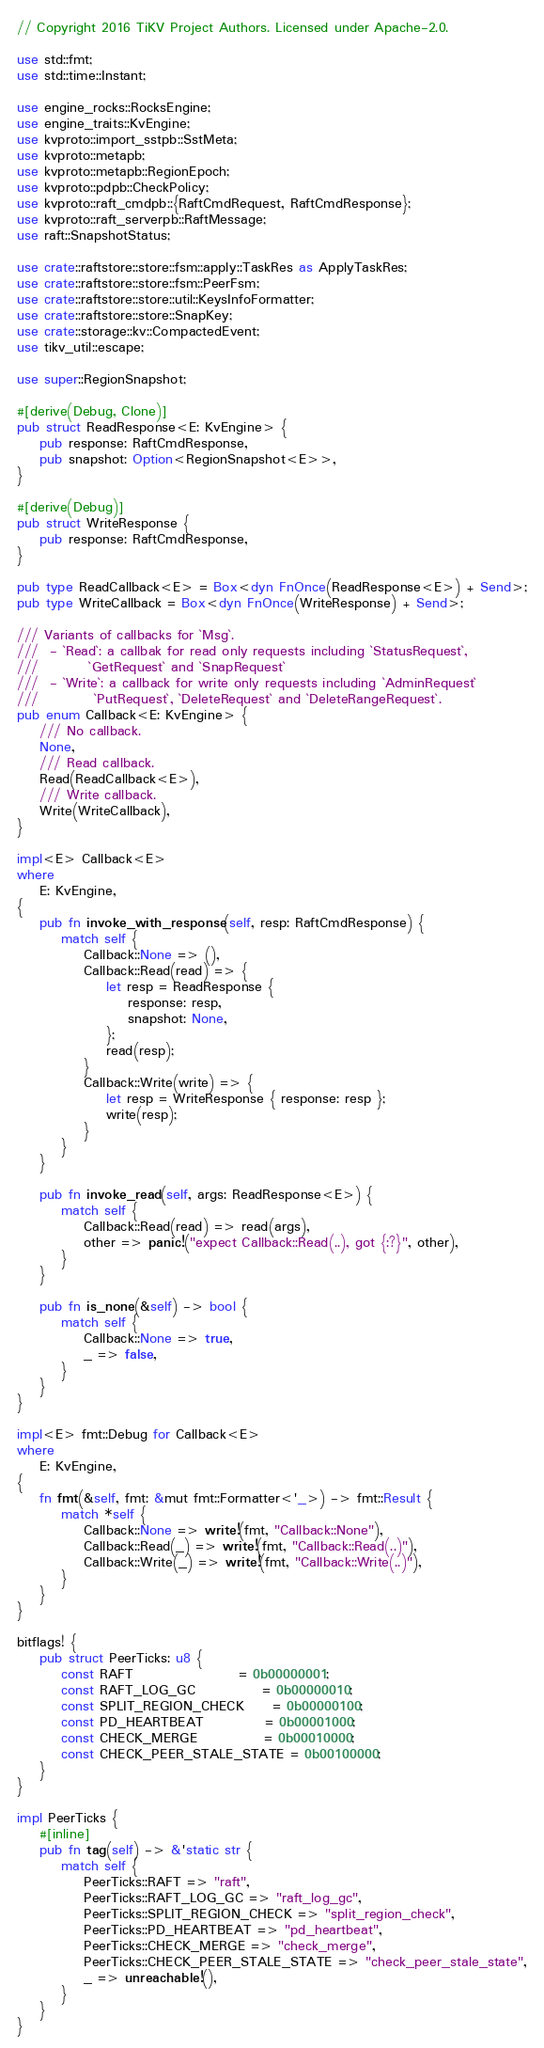Convert code to text. <code><loc_0><loc_0><loc_500><loc_500><_Rust_>// Copyright 2016 TiKV Project Authors. Licensed under Apache-2.0.

use std::fmt;
use std::time::Instant;

use engine_rocks::RocksEngine;
use engine_traits::KvEngine;
use kvproto::import_sstpb::SstMeta;
use kvproto::metapb;
use kvproto::metapb::RegionEpoch;
use kvproto::pdpb::CheckPolicy;
use kvproto::raft_cmdpb::{RaftCmdRequest, RaftCmdResponse};
use kvproto::raft_serverpb::RaftMessage;
use raft::SnapshotStatus;

use crate::raftstore::store::fsm::apply::TaskRes as ApplyTaskRes;
use crate::raftstore::store::fsm::PeerFsm;
use crate::raftstore::store::util::KeysInfoFormatter;
use crate::raftstore::store::SnapKey;
use crate::storage::kv::CompactedEvent;
use tikv_util::escape;

use super::RegionSnapshot;

#[derive(Debug, Clone)]
pub struct ReadResponse<E: KvEngine> {
    pub response: RaftCmdResponse,
    pub snapshot: Option<RegionSnapshot<E>>,
}

#[derive(Debug)]
pub struct WriteResponse {
    pub response: RaftCmdResponse,
}

pub type ReadCallback<E> = Box<dyn FnOnce(ReadResponse<E>) + Send>;
pub type WriteCallback = Box<dyn FnOnce(WriteResponse) + Send>;

/// Variants of callbacks for `Msg`.
///  - `Read`: a callbak for read only requests including `StatusRequest`,
///         `GetRequest` and `SnapRequest`
///  - `Write`: a callback for write only requests including `AdminRequest`
///          `PutRequest`, `DeleteRequest` and `DeleteRangeRequest`.
pub enum Callback<E: KvEngine> {
    /// No callback.
    None,
    /// Read callback.
    Read(ReadCallback<E>),
    /// Write callback.
    Write(WriteCallback),
}

impl<E> Callback<E>
where
    E: KvEngine,
{
    pub fn invoke_with_response(self, resp: RaftCmdResponse) {
        match self {
            Callback::None => (),
            Callback::Read(read) => {
                let resp = ReadResponse {
                    response: resp,
                    snapshot: None,
                };
                read(resp);
            }
            Callback::Write(write) => {
                let resp = WriteResponse { response: resp };
                write(resp);
            }
        }
    }

    pub fn invoke_read(self, args: ReadResponse<E>) {
        match self {
            Callback::Read(read) => read(args),
            other => panic!("expect Callback::Read(..), got {:?}", other),
        }
    }

    pub fn is_none(&self) -> bool {
        match self {
            Callback::None => true,
            _ => false,
        }
    }
}

impl<E> fmt::Debug for Callback<E>
where
    E: KvEngine,
{
    fn fmt(&self, fmt: &mut fmt::Formatter<'_>) -> fmt::Result {
        match *self {
            Callback::None => write!(fmt, "Callback::None"),
            Callback::Read(_) => write!(fmt, "Callback::Read(..)"),
            Callback::Write(_) => write!(fmt, "Callback::Write(..)"),
        }
    }
}

bitflags! {
    pub struct PeerTicks: u8 {
        const RAFT                   = 0b00000001;
        const RAFT_LOG_GC            = 0b00000010;
        const SPLIT_REGION_CHECK     = 0b00000100;
        const PD_HEARTBEAT           = 0b00001000;
        const CHECK_MERGE            = 0b00010000;
        const CHECK_PEER_STALE_STATE = 0b00100000;
    }
}

impl PeerTicks {
    #[inline]
    pub fn tag(self) -> &'static str {
        match self {
            PeerTicks::RAFT => "raft",
            PeerTicks::RAFT_LOG_GC => "raft_log_gc",
            PeerTicks::SPLIT_REGION_CHECK => "split_region_check",
            PeerTicks::PD_HEARTBEAT => "pd_heartbeat",
            PeerTicks::CHECK_MERGE => "check_merge",
            PeerTicks::CHECK_PEER_STALE_STATE => "check_peer_stale_state",
            _ => unreachable!(),
        }
    }
}
</code> 